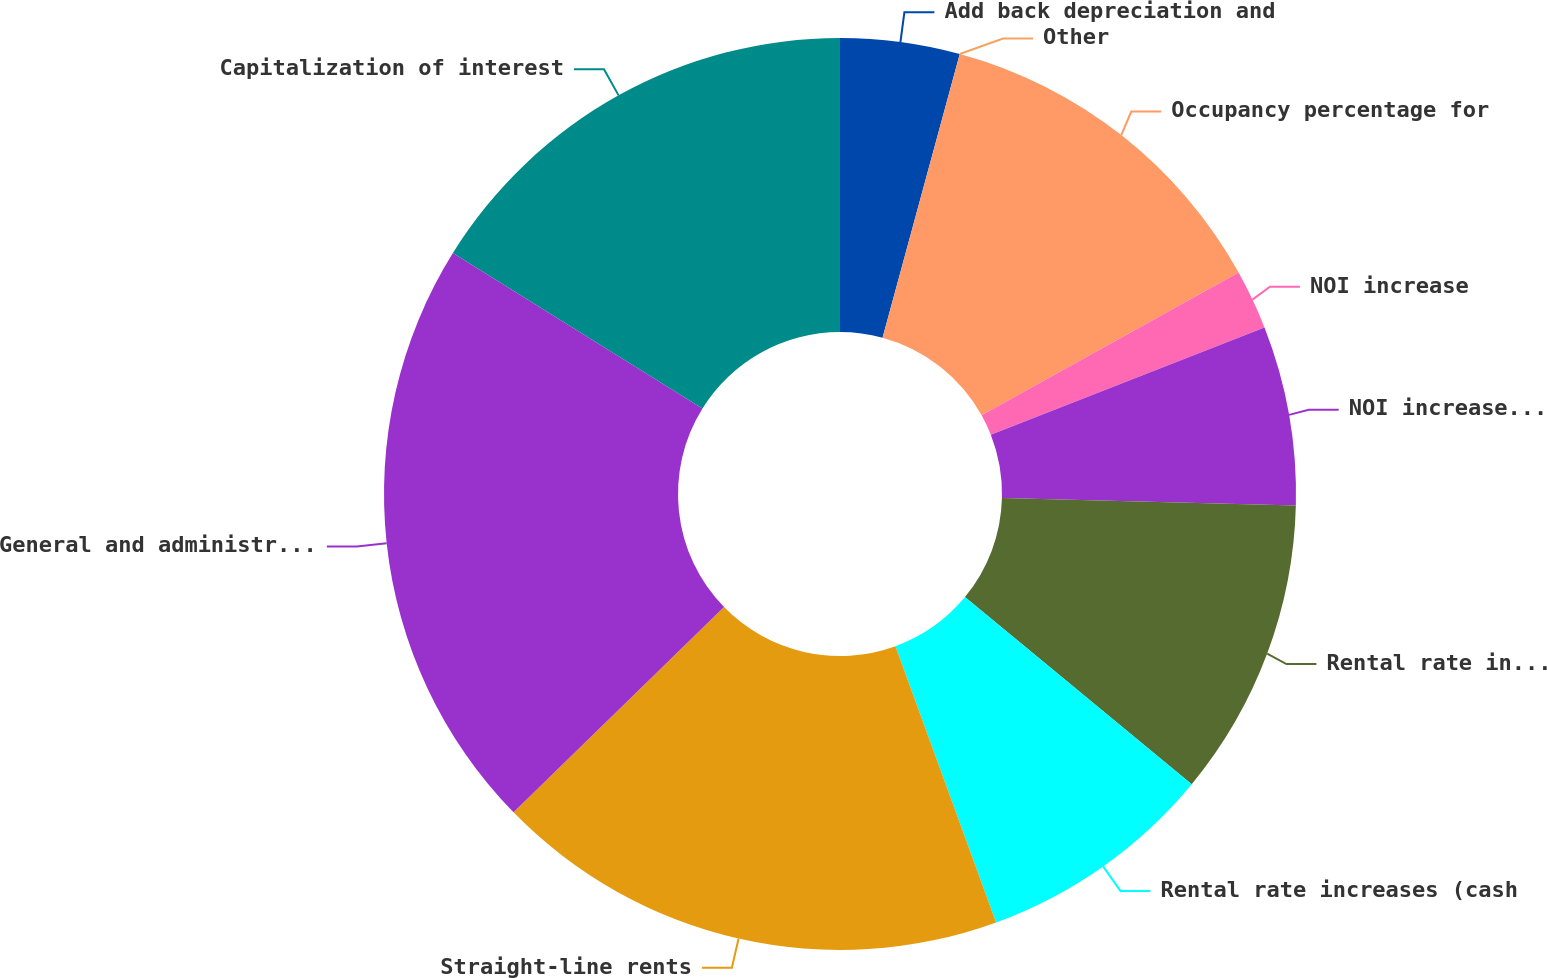<chart> <loc_0><loc_0><loc_500><loc_500><pie_chart><fcel>Add back depreciation and<fcel>Other<fcel>Occupancy percentage for<fcel>NOI increase<fcel>NOI increase (cash basis)<fcel>Rental rate increases<fcel>Rental rate increases (cash<fcel>Straight-line rents<fcel>General and administrative<fcel>Capitalization of interest<nl><fcel>4.23%<fcel>0.0%<fcel>12.7%<fcel>2.12%<fcel>6.35%<fcel>10.58%<fcel>8.46%<fcel>18.26%<fcel>21.16%<fcel>16.14%<nl></chart> 